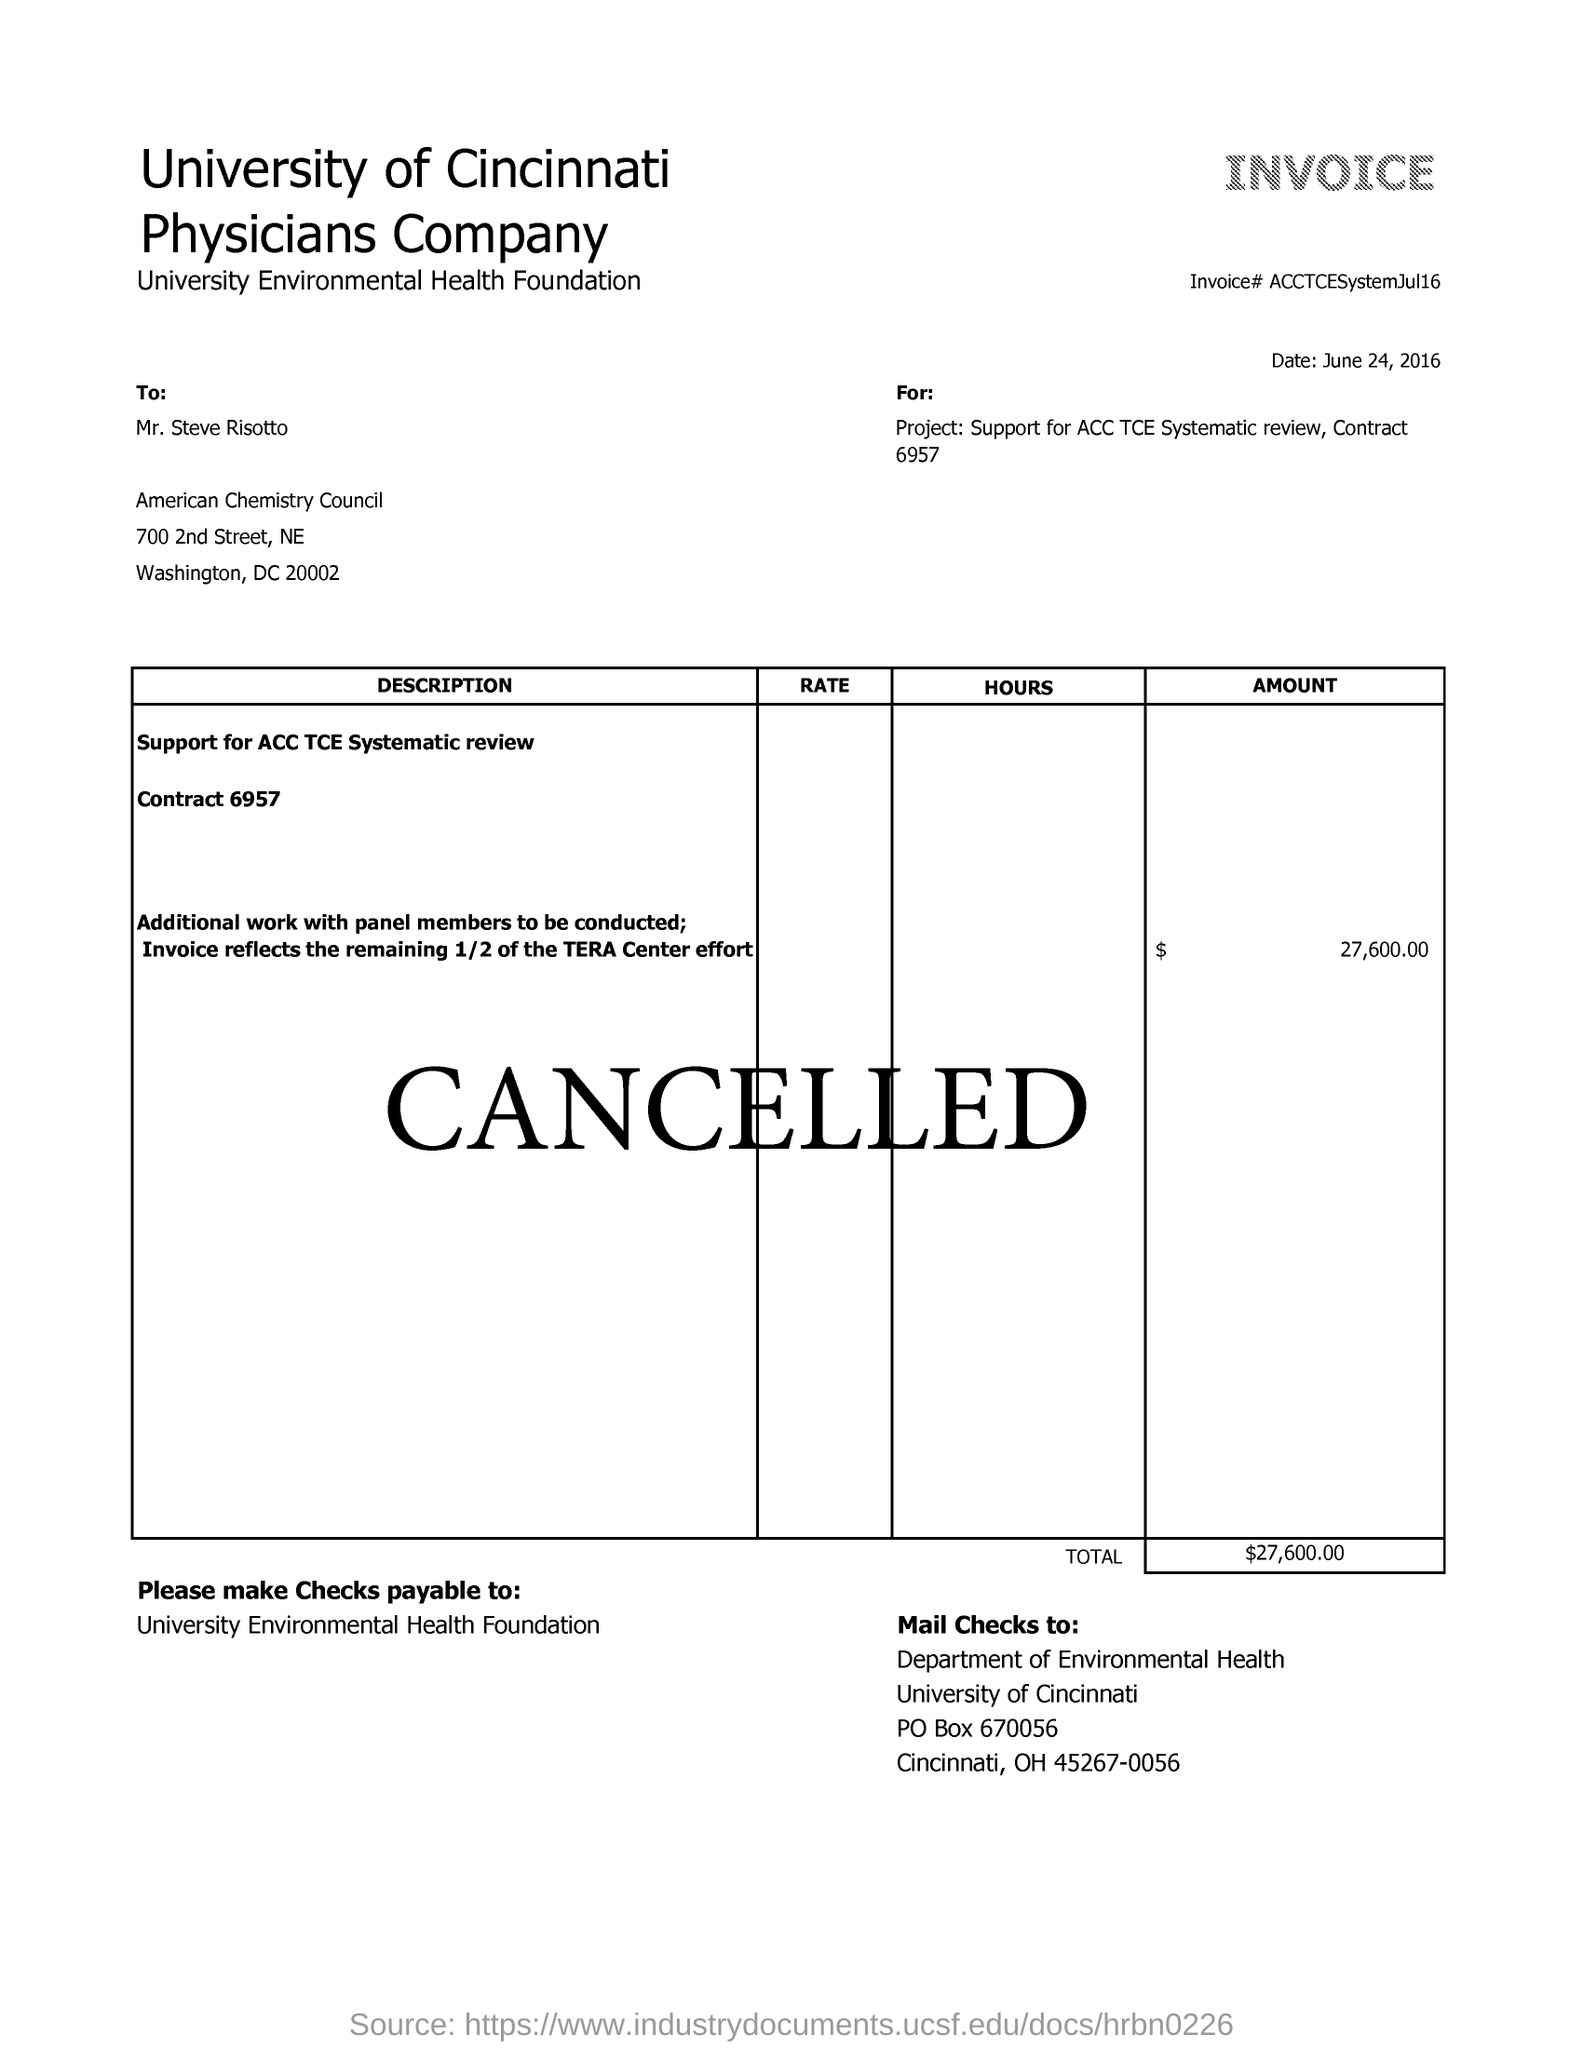What is the date mentioned in this invoice?
Offer a terse response. June 24, 2016. What is the total amount of the invoice?
Your answer should be compact. $27,600.00. What is the invoice# given?
Offer a very short reply. ACCTCESystemJul16. 